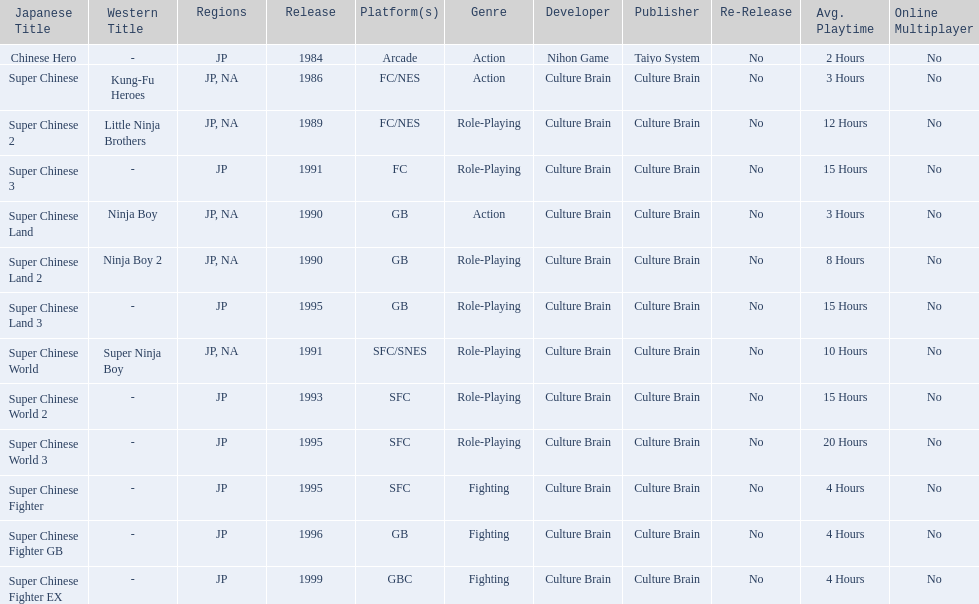How many action games were released in north america? 2. 